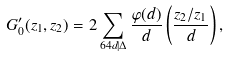<formula> <loc_0><loc_0><loc_500><loc_500>G ^ { \prime } _ { 0 } ( z _ { 1 } , z _ { 2 } ) = 2 \sum _ { 6 4 d | \Delta } \frac { \varphi ( d ) } { d } \left ( \frac { z _ { 2 } / z _ { 1 } } { d } \right ) ,</formula> 